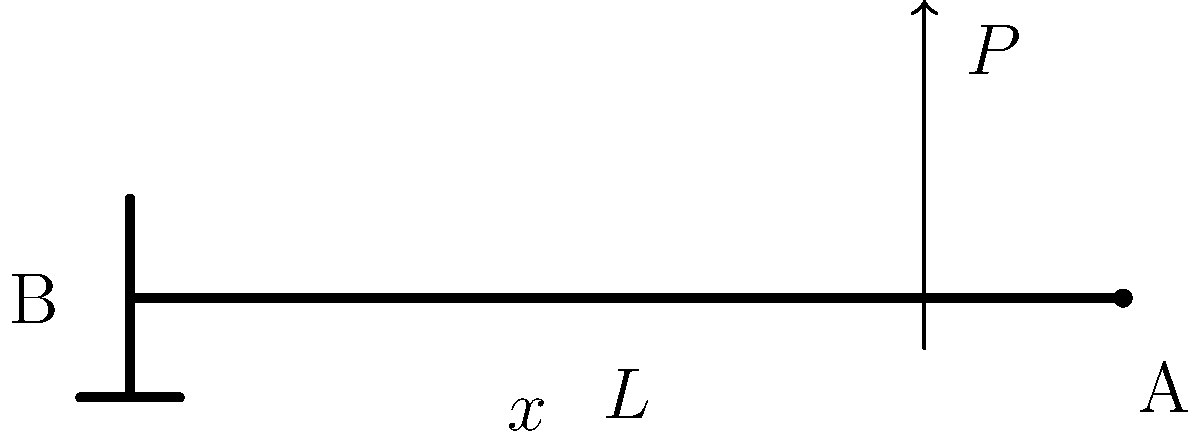A cantilever beam of length $L$ is fixed at one end (B) and free at the other end (A). A point load $P$ is applied at a distance $x$ from the fixed end. Determine the expression for the bending stress $\sigma$ at any point along the beam in terms of $P$, $x$, $L$, and the beam's moment of inertia $I$ and height $h$. To find the bending stress distribution in the cantilever beam, we'll follow these steps:

1) First, determine the bending moment $M$ at any point along the beam:
   $M = P(L-x)$

2) The general equation for bending stress is:
   $\sigma = \frac{My}{I}$
   where $y$ is the distance from the neutral axis to the point of interest.

3) The maximum bending stress occurs at the outer fibers of the beam, where $y = \frac{h}{2}$:
   $\sigma_{max} = \frac{M(\frac{h}{2})}{I}$

4) Substitute the expression for $M$ into the stress equation:
   $\sigma_{max} = \frac{P(L-x)(\frac{h}{2})}{I}$

5) Simplify:
   $\sigma_{max} = \frac{Ph(L-x)}{2I}$

This expression gives the maximum bending stress at any point $x$ along the beam. The stress varies linearly across the height of the beam, from maximum tension at the top to maximum compression at the bottom (or vice versa, depending on the direction of the applied load).
Answer: $\sigma = \frac{Ph(L-x)}{2I}$ 